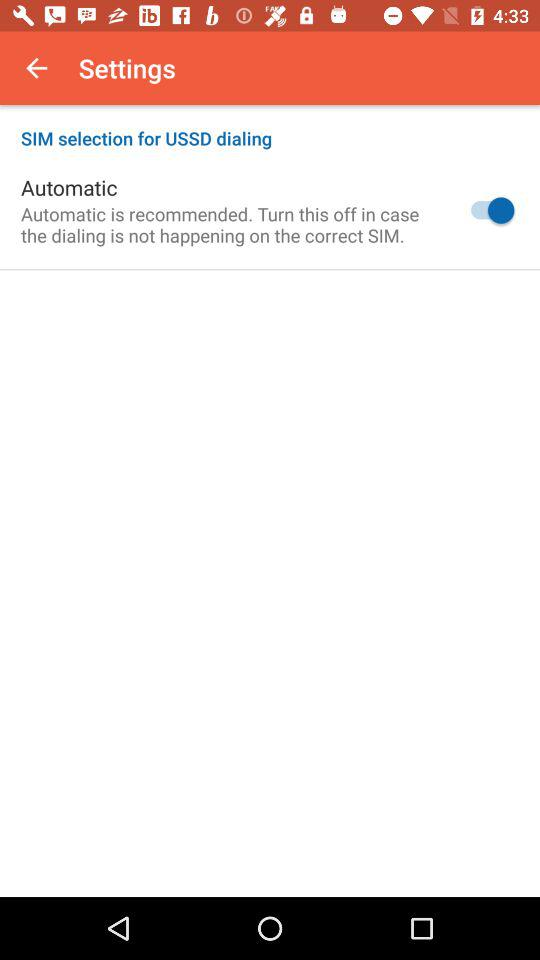What is the status of "Automatic"? The status is "on". 